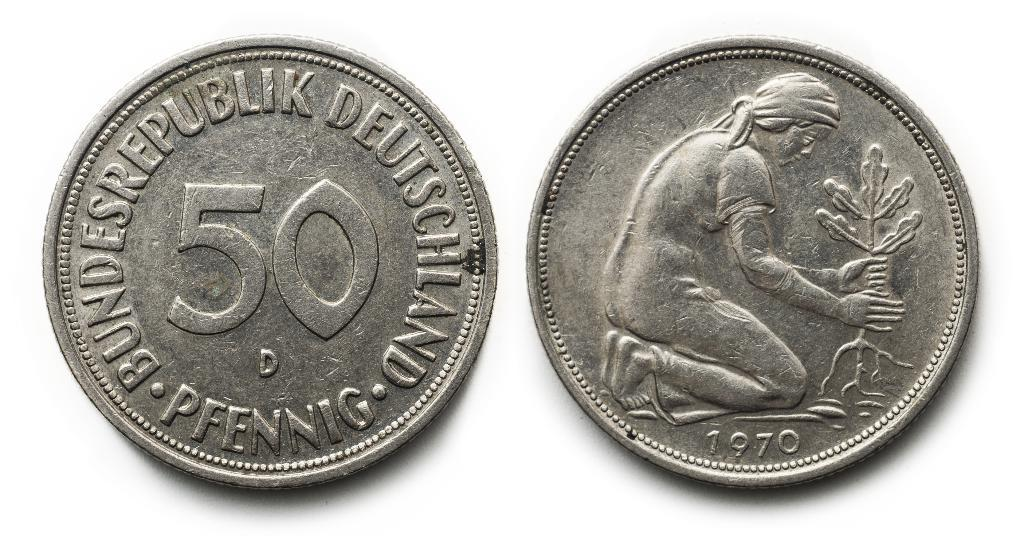<image>
Relay a brief, clear account of the picture shown. Silver coins with the number fifty written on one side. 